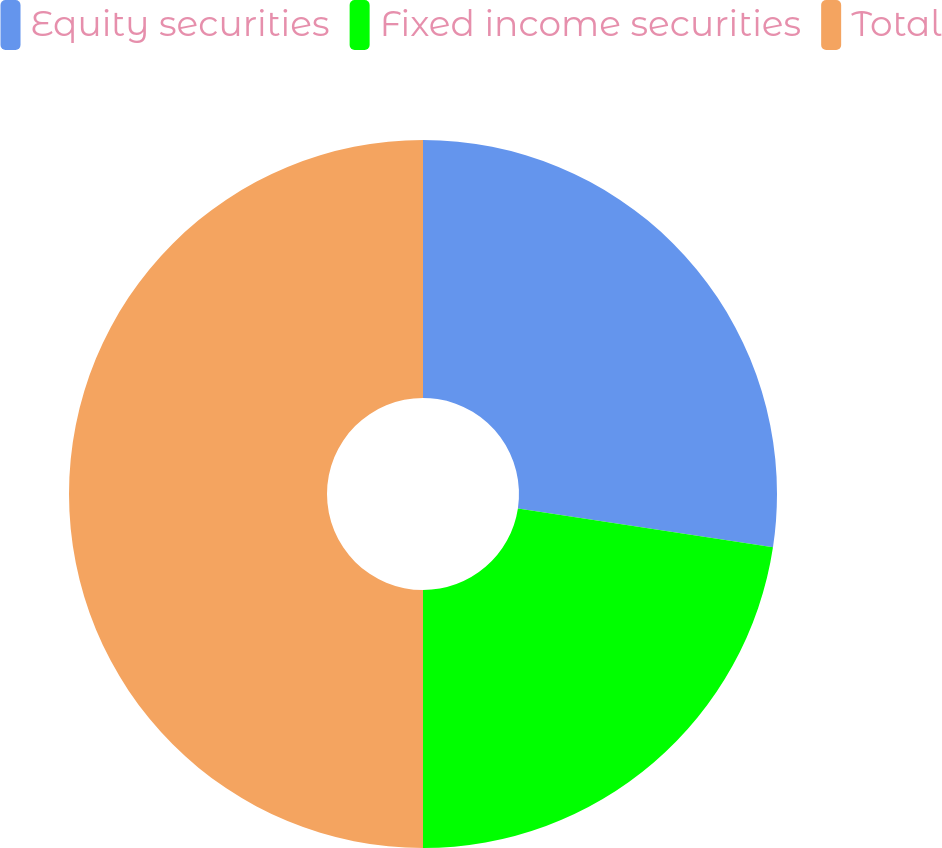<chart> <loc_0><loc_0><loc_500><loc_500><pie_chart><fcel>Equity securities<fcel>Fixed income securities<fcel>Total<nl><fcel>27.4%<fcel>22.6%<fcel>50.0%<nl></chart> 